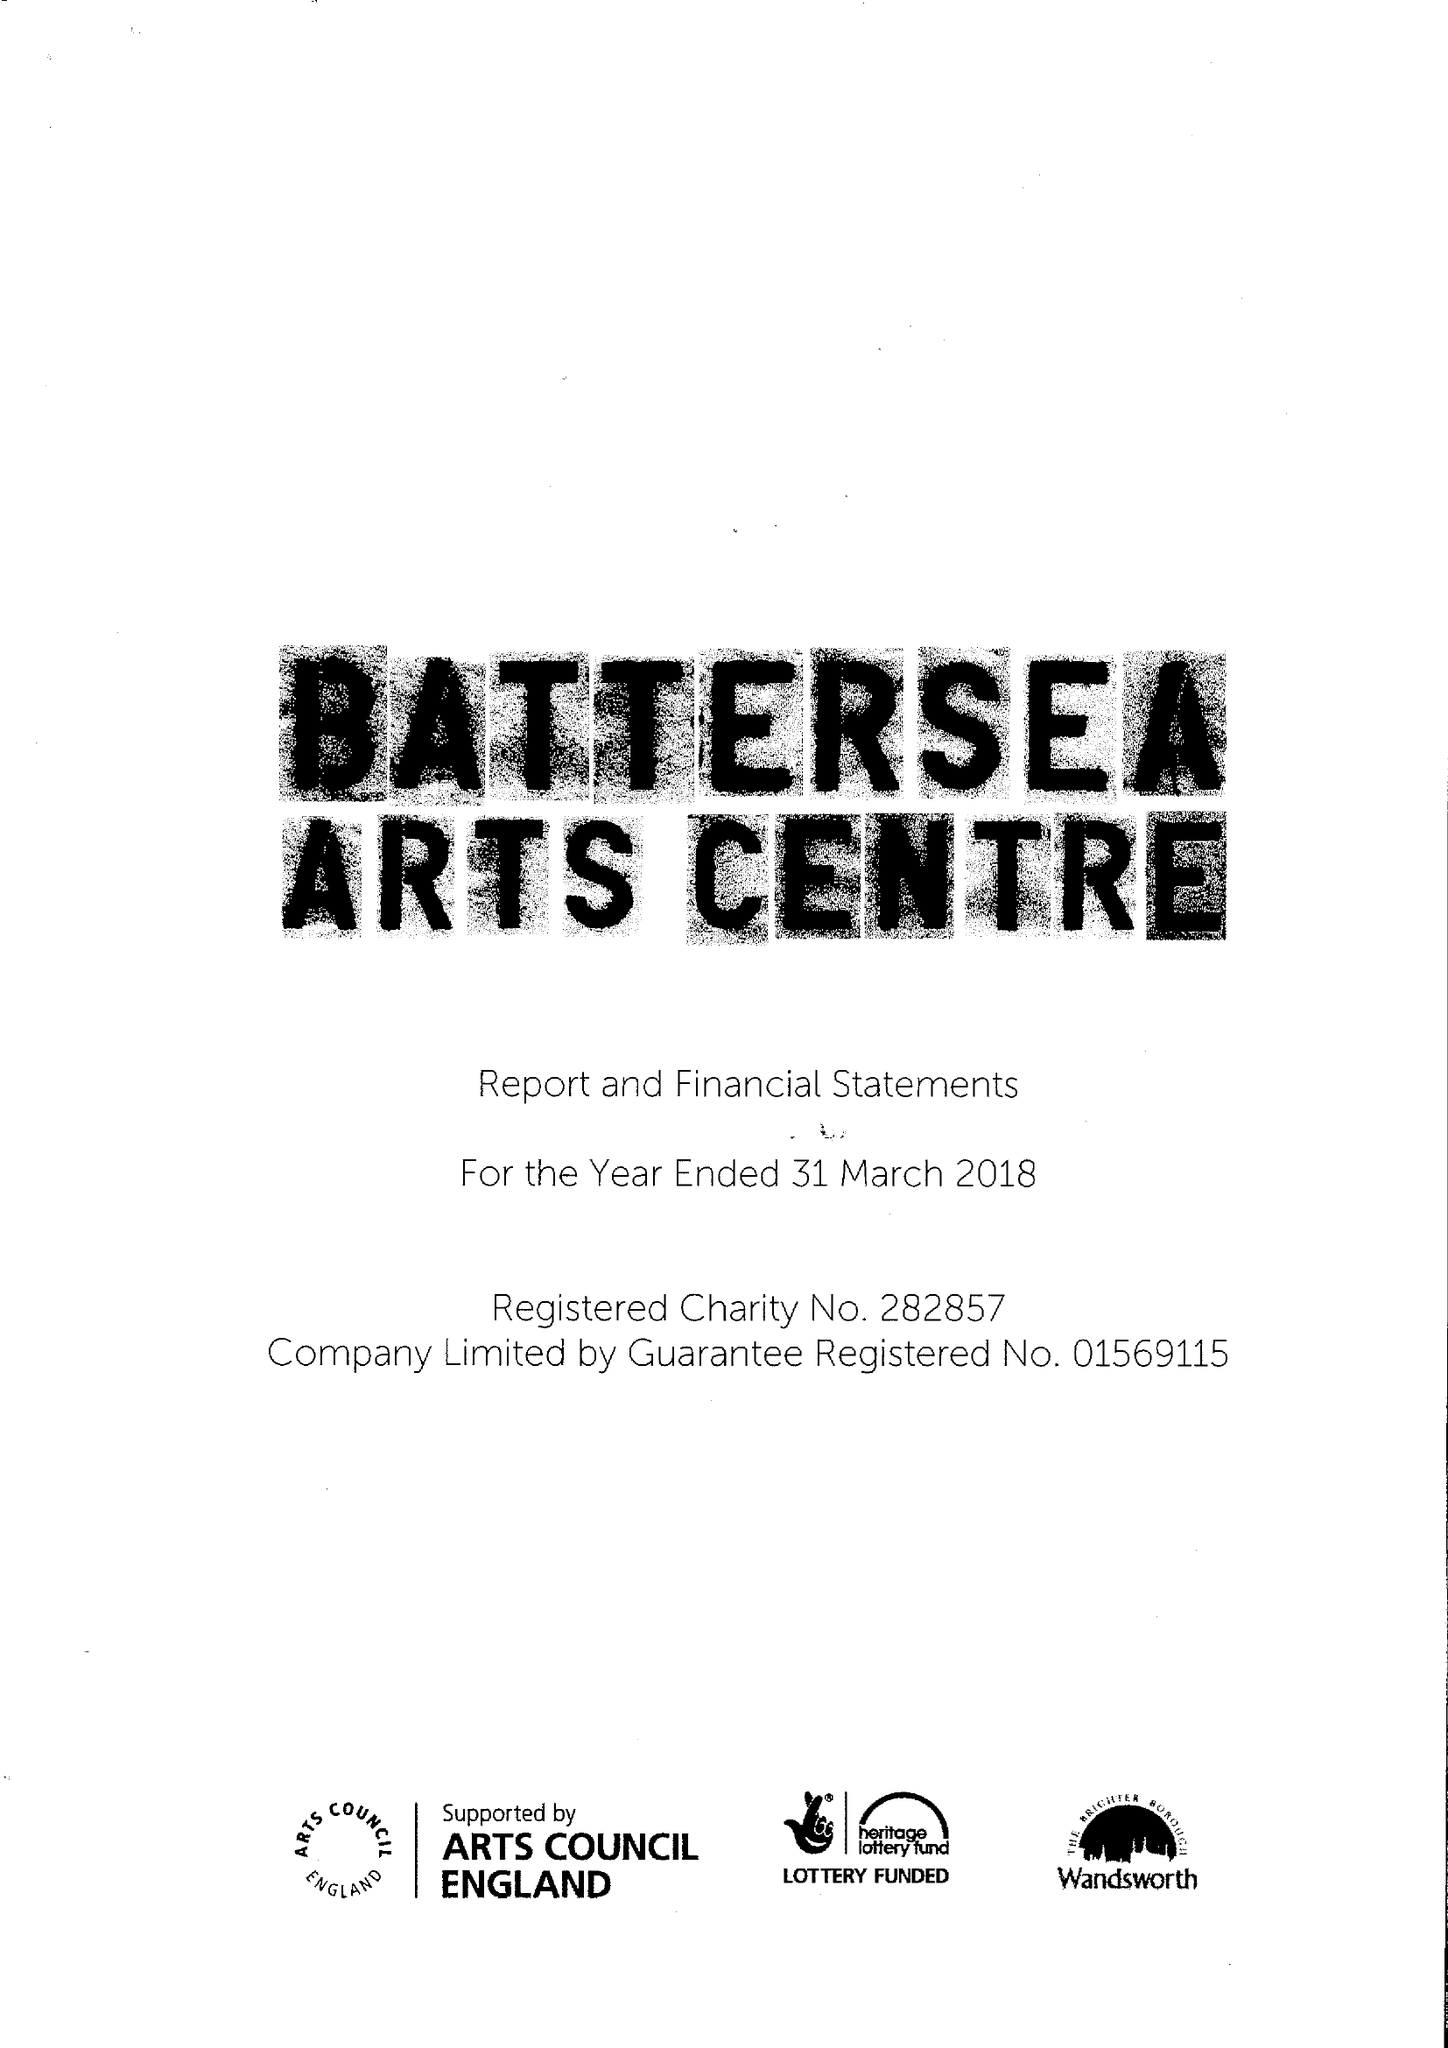What is the value for the address__postcode?
Answer the question using a single word or phrase. SW11 5TN 